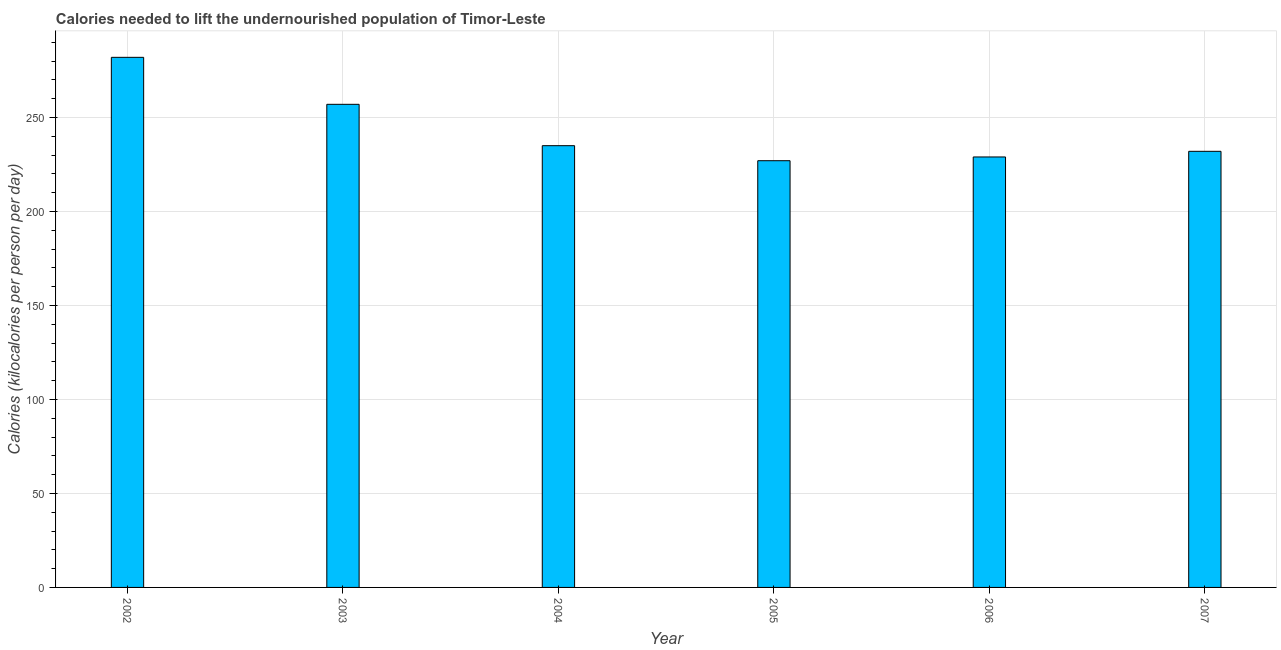Does the graph contain grids?
Give a very brief answer. Yes. What is the title of the graph?
Ensure brevity in your answer.  Calories needed to lift the undernourished population of Timor-Leste. What is the label or title of the Y-axis?
Make the answer very short. Calories (kilocalories per person per day). What is the depth of food deficit in 2003?
Your answer should be very brief. 257. Across all years, what is the maximum depth of food deficit?
Provide a succinct answer. 282. Across all years, what is the minimum depth of food deficit?
Offer a terse response. 227. In which year was the depth of food deficit maximum?
Your response must be concise. 2002. What is the sum of the depth of food deficit?
Offer a terse response. 1462. What is the difference between the depth of food deficit in 2002 and 2006?
Ensure brevity in your answer.  53. What is the average depth of food deficit per year?
Your answer should be compact. 243. What is the median depth of food deficit?
Your answer should be compact. 233.5. In how many years, is the depth of food deficit greater than 60 kilocalories?
Your answer should be very brief. 6. What is the ratio of the depth of food deficit in 2004 to that in 2007?
Offer a very short reply. 1.01. Is the depth of food deficit in 2004 less than that in 2005?
Offer a terse response. No. Is the difference between the depth of food deficit in 2002 and 2005 greater than the difference between any two years?
Offer a terse response. Yes. Is the sum of the depth of food deficit in 2003 and 2005 greater than the maximum depth of food deficit across all years?
Provide a short and direct response. Yes. What is the difference between the highest and the lowest depth of food deficit?
Provide a short and direct response. 55. Are all the bars in the graph horizontal?
Give a very brief answer. No. How many years are there in the graph?
Offer a terse response. 6. What is the difference between two consecutive major ticks on the Y-axis?
Your answer should be very brief. 50. Are the values on the major ticks of Y-axis written in scientific E-notation?
Your answer should be compact. No. What is the Calories (kilocalories per person per day) of 2002?
Keep it short and to the point. 282. What is the Calories (kilocalories per person per day) of 2003?
Offer a very short reply. 257. What is the Calories (kilocalories per person per day) in 2004?
Give a very brief answer. 235. What is the Calories (kilocalories per person per day) of 2005?
Your response must be concise. 227. What is the Calories (kilocalories per person per day) in 2006?
Give a very brief answer. 229. What is the Calories (kilocalories per person per day) in 2007?
Make the answer very short. 232. What is the difference between the Calories (kilocalories per person per day) in 2002 and 2006?
Your answer should be compact. 53. What is the difference between the Calories (kilocalories per person per day) in 2003 and 2005?
Your answer should be compact. 30. What is the difference between the Calories (kilocalories per person per day) in 2003 and 2006?
Ensure brevity in your answer.  28. What is the difference between the Calories (kilocalories per person per day) in 2003 and 2007?
Offer a terse response. 25. What is the difference between the Calories (kilocalories per person per day) in 2005 and 2006?
Your answer should be very brief. -2. What is the difference between the Calories (kilocalories per person per day) in 2005 and 2007?
Give a very brief answer. -5. What is the difference between the Calories (kilocalories per person per day) in 2006 and 2007?
Offer a terse response. -3. What is the ratio of the Calories (kilocalories per person per day) in 2002 to that in 2003?
Offer a very short reply. 1.1. What is the ratio of the Calories (kilocalories per person per day) in 2002 to that in 2005?
Give a very brief answer. 1.24. What is the ratio of the Calories (kilocalories per person per day) in 2002 to that in 2006?
Give a very brief answer. 1.23. What is the ratio of the Calories (kilocalories per person per day) in 2002 to that in 2007?
Offer a terse response. 1.22. What is the ratio of the Calories (kilocalories per person per day) in 2003 to that in 2004?
Offer a very short reply. 1.09. What is the ratio of the Calories (kilocalories per person per day) in 2003 to that in 2005?
Provide a short and direct response. 1.13. What is the ratio of the Calories (kilocalories per person per day) in 2003 to that in 2006?
Offer a terse response. 1.12. What is the ratio of the Calories (kilocalories per person per day) in 2003 to that in 2007?
Make the answer very short. 1.11. What is the ratio of the Calories (kilocalories per person per day) in 2004 to that in 2005?
Ensure brevity in your answer.  1.03. What is the ratio of the Calories (kilocalories per person per day) in 2004 to that in 2006?
Give a very brief answer. 1.03. What is the ratio of the Calories (kilocalories per person per day) in 2005 to that in 2007?
Your answer should be compact. 0.98. What is the ratio of the Calories (kilocalories per person per day) in 2006 to that in 2007?
Provide a succinct answer. 0.99. 